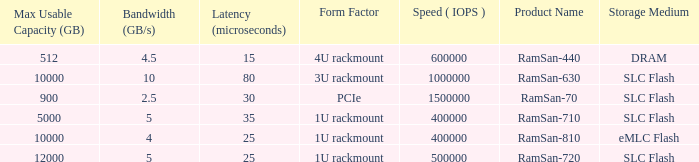What is the ramsan-810 transfer delay? 1.0. 